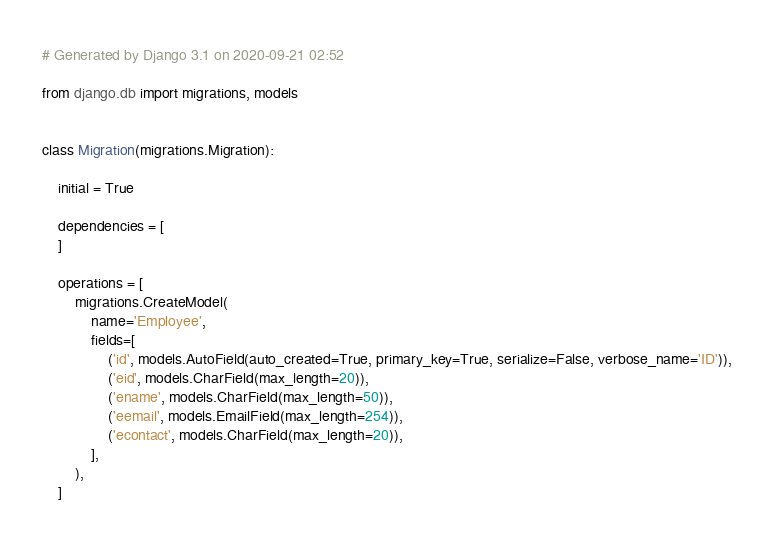Convert code to text. <code><loc_0><loc_0><loc_500><loc_500><_Python_># Generated by Django 3.1 on 2020-09-21 02:52

from django.db import migrations, models


class Migration(migrations.Migration):

    initial = True

    dependencies = [
    ]

    operations = [
        migrations.CreateModel(
            name='Employee',
            fields=[
                ('id', models.AutoField(auto_created=True, primary_key=True, serialize=False, verbose_name='ID')),
                ('eid', models.CharField(max_length=20)),
                ('ename', models.CharField(max_length=50)),
                ('eemail', models.EmailField(max_length=254)),
                ('econtact', models.CharField(max_length=20)),
            ],
        ),
    ]
</code> 